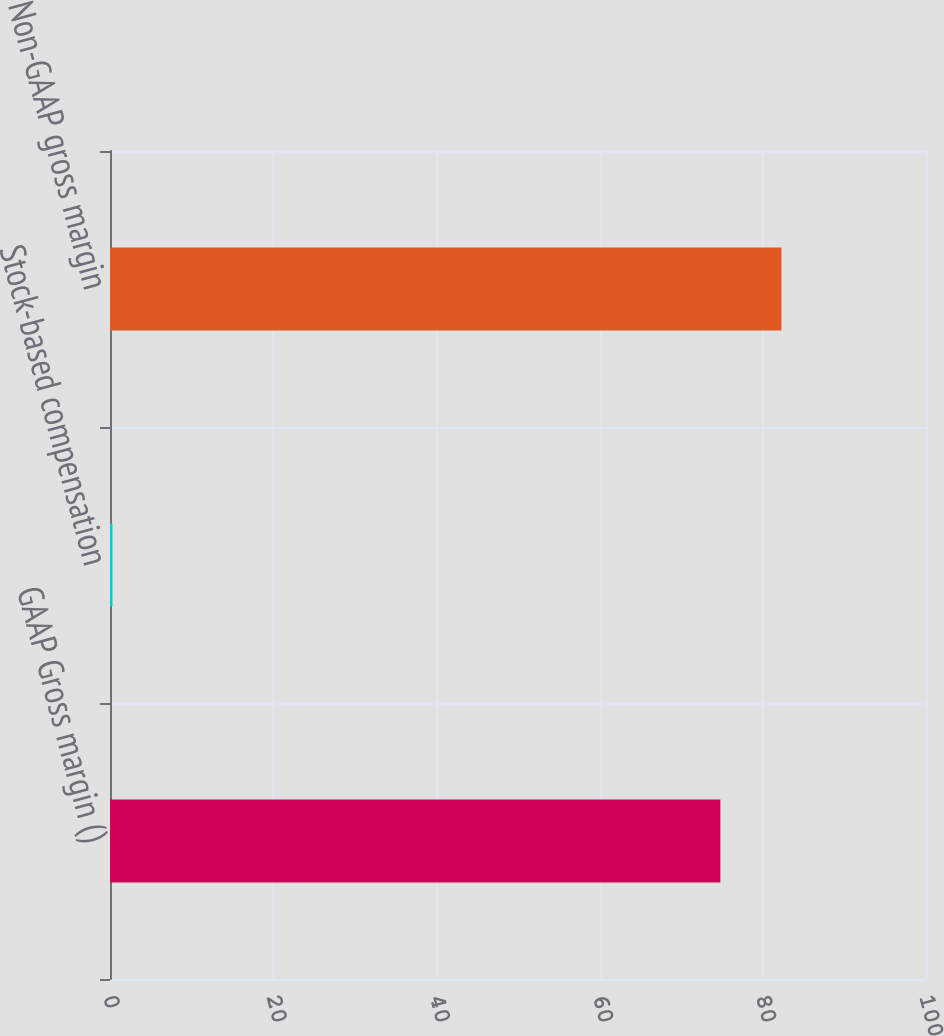<chart> <loc_0><loc_0><loc_500><loc_500><bar_chart><fcel>GAAP Gross margin ()<fcel>Stock-based compensation<fcel>Non-GAAP gross margin<nl><fcel>74.8<fcel>0.3<fcel>82.28<nl></chart> 